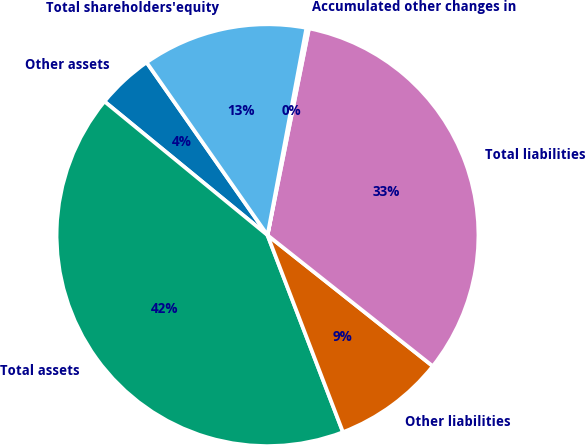Convert chart to OTSL. <chart><loc_0><loc_0><loc_500><loc_500><pie_chart><fcel>Other assets<fcel>Total assets<fcel>Other liabilities<fcel>Total liabilities<fcel>Accumulated other changes in<fcel>Total shareholders'equity<nl><fcel>4.35%<fcel>41.76%<fcel>8.51%<fcel>32.52%<fcel>0.2%<fcel>12.67%<nl></chart> 